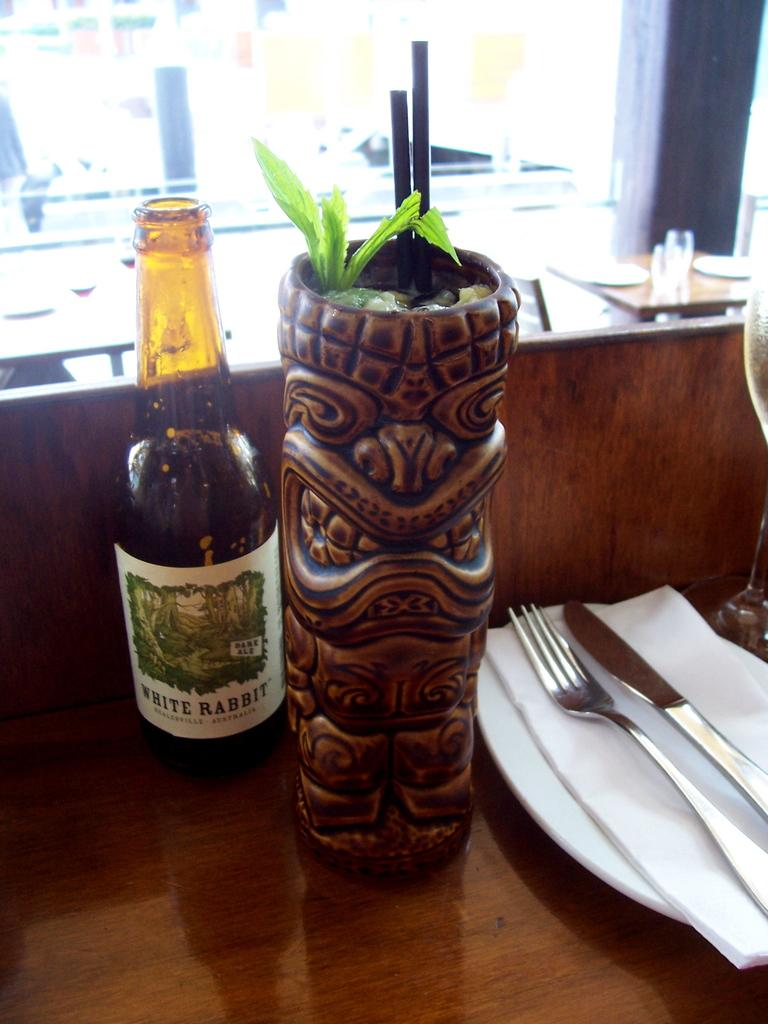<image>
Summarize the visual content of the image. A bottle of the drink White Rabbit next to a tiki glass 